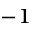Convert formula to latex. <formula><loc_0><loc_0><loc_500><loc_500>^ { - 1 }</formula> 